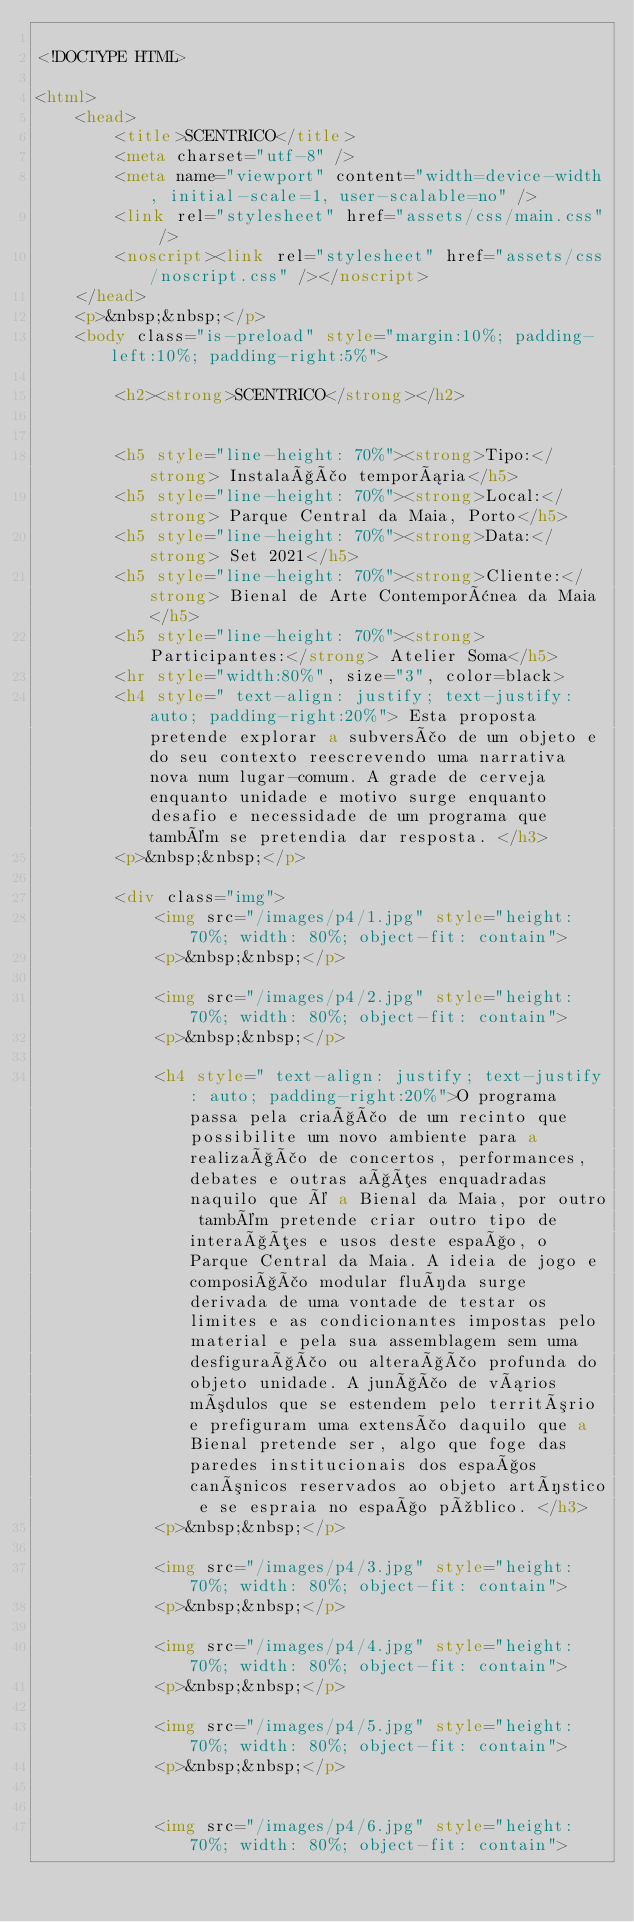<code> <loc_0><loc_0><loc_500><loc_500><_HTML_>
<!DOCTYPE HTML>

<html>
	<head>
		<title>SCENTRICO</title>
		<meta charset="utf-8" />
		<meta name="viewport" content="width=device-width, initial-scale=1, user-scalable=no" />
		<link rel="stylesheet" href="assets/css/main.css" />
		<noscript><link rel="stylesheet" href="assets/css/noscript.css" /></noscript>
	</head>
	<p>&nbsp;&nbsp;</p>
	<body class="is-preload" style="margin:10%; padding-left:10%; padding-right:5%">

		<h2><strong>SCENTRICO</strong></h2>

 
		<h5 style="line-height: 70%"><strong>Tipo:</strong> Instalação temporária</h5>
		<h5 style="line-height: 70%"><strong>Local:</strong> Parque Central da Maia, Porto</h5>
		<h5 style="line-height: 70%"><strong>Data:</strong> Set 2021</h5>
		<h5 style="line-height: 70%"><strong>Cliente:</strong> Bienal de Arte Contemporânea da Maia</h5>
		<h5 style="line-height: 70%"><strong>Participantes:</strong> Atelier Soma</h5>
		<hr style="width:80%", size="3", color=black>
		<h4 style=" text-align: justify; text-justify: auto; padding-right:20%"> Esta proposta pretende explorar a subversão de um objeto e do seu contexto reescrevendo uma narrativa nova num lugar-comum. A grade de cerveja enquanto unidade e motivo surge enquanto desafio e necessidade de um programa que também se pretendia dar resposta. </h3>
		<p>&nbsp;&nbsp;</p>

		<div class="img">
			<img src="/images/p4/1.jpg" style="height: 70%; width: 80%; object-fit: contain">
			<p>&nbsp;&nbsp;</p>

			<img src="/images/p4/2.jpg" style="height: 70%; width: 80%; object-fit: contain">
			<p>&nbsp;&nbsp;</p>

			<h4 style=" text-align: justify; text-justify: auto; padding-right:20%">O programa passa pela criação de um recinto que possibilite um novo ambiente para a realização de concertos, performances, debates e outras ações enquadradas naquilo que é a Bienal da Maia, por outro também pretende criar outro tipo de interações e usos deste espaço, o Parque Central da Maia. A ideia de jogo e composição modular fluída surge derivada de uma vontade de testar os limites e as condicionantes impostas pelo material e pela sua assemblagem sem uma desfiguração ou alteração profunda do objeto unidade. A junção de vários módulos que se estendem pelo território e prefiguram uma extensão daquilo que a Bienal pretende ser, algo que foge das paredes institucionais dos espaços canónicos reservados ao objeto artístico e se espraia no espaço público. </h3>
			<p>&nbsp;&nbsp;</p>

			<img src="/images/p4/3.jpg" style="height: 70%; width: 80%; object-fit: contain">
			<p>&nbsp;&nbsp;</p>

			<img src="/images/p4/4.jpg" style="height: 70%; width: 80%; object-fit: contain">
			<p>&nbsp;&nbsp;</p>

			<img src="/images/p4/5.jpg" style="height: 70%; width: 80%; object-fit: contain">
			<p>&nbsp;&nbsp;</p>


			<img src="/images/p4/6.jpg" style="height: 70%; width: 80%; object-fit: contain"></code> 